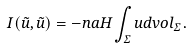Convert formula to latex. <formula><loc_0><loc_0><loc_500><loc_500>I ( \tilde { u } , \tilde { u } ) = - n a H \int _ { \Sigma } u d v o l _ { \Sigma } \, .</formula> 